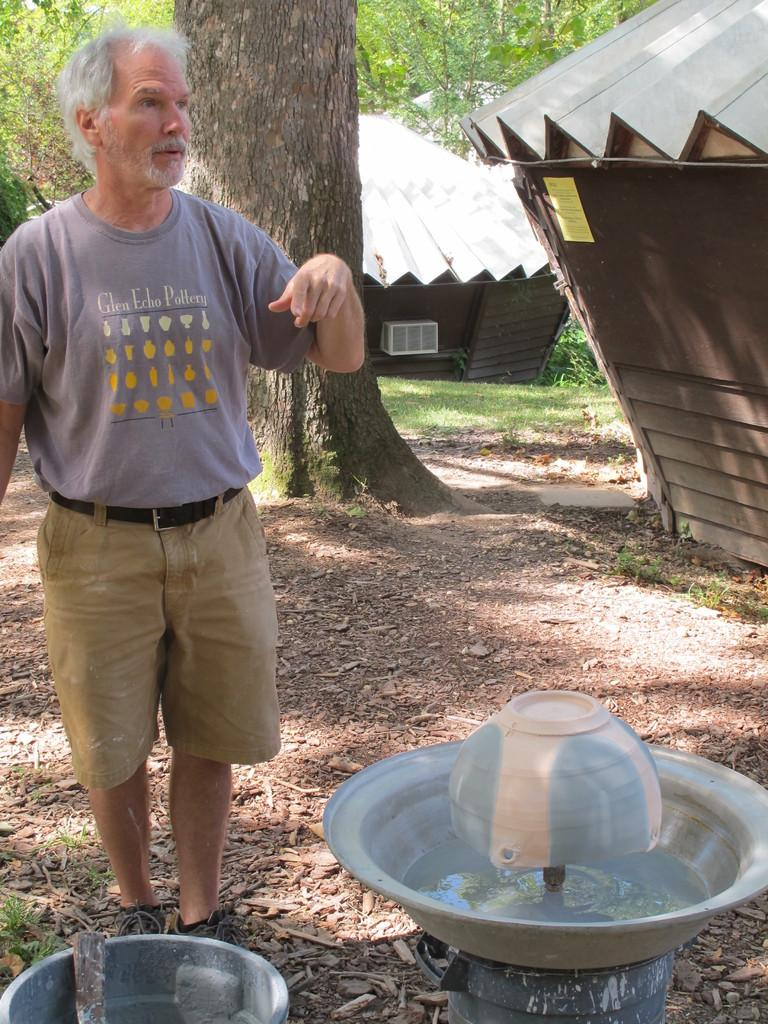Provide a one-sentence caption for the provided image. A man is working on making clay vases with a shirt that says Glen Echo Pottery. 